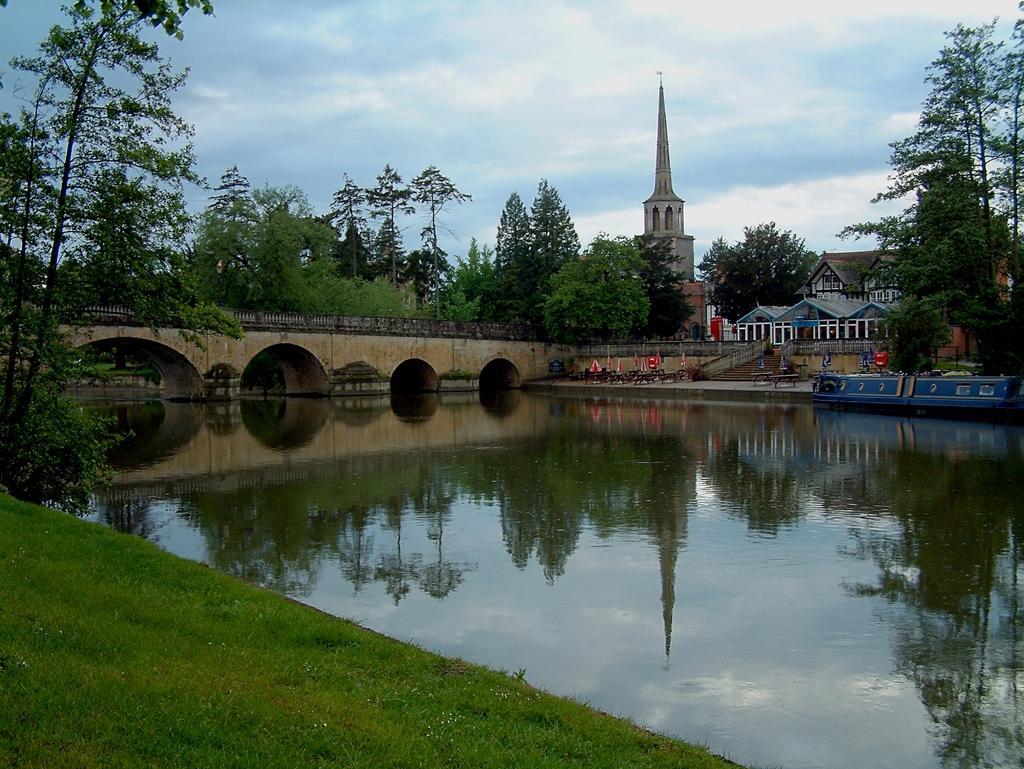How would you summarize this image in a sentence or two? In this image in the front there's grass on the ground. In the center there is water. In the background there is a bridge, there are buildings and there is a tower and there are trees and the sky is cloudy. 